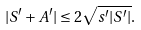<formula> <loc_0><loc_0><loc_500><loc_500>| S ^ { \prime } + A ^ { \prime } | \leq 2 \sqrt { s ^ { \prime } | S ^ { \prime } | } .</formula> 